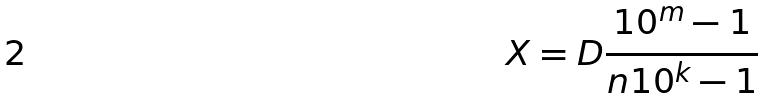<formula> <loc_0><loc_0><loc_500><loc_500>X = D \frac { 1 0 ^ { m } - 1 } { n 1 0 ^ { k } - 1 }</formula> 